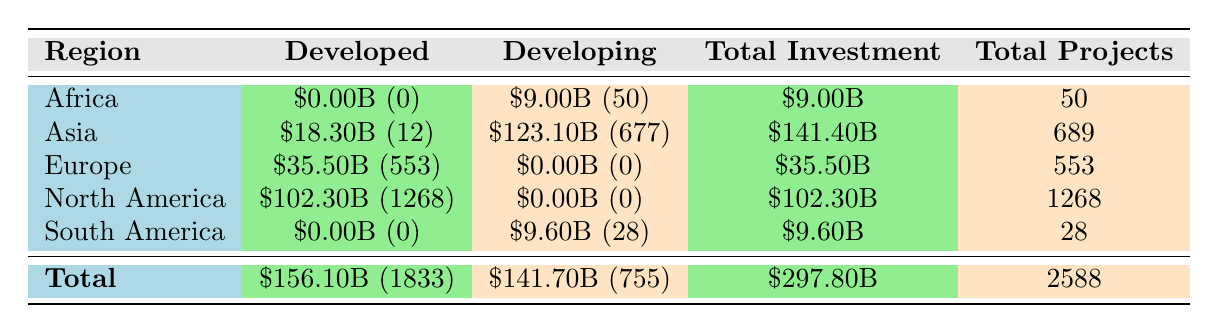What is the total investment in developed nations in Africa? According to the table, the investment in developed nations in Africa is \$0.00B. The amount is clearly listed under the "Developed" column for the "Africa" region.
Answer: 0.00B Which region has the highest total investment? By looking at the "Total Investment" column and comparing the values, Asia has the highest total investment at \$141.40B. This is determined by reviewing all total investment amounts from each region.
Answer: Asia: 141.40B How many projects are there in total across all developing nations? The total number of projects listed under "Developing" is 755, as specified in the table. This is simply retrieved from the corresponding column.
Answer: 755 What is the difference in total investment between developed and developing nations? The total investment for developed nations is \$156.10B, while for developing nations it is \$141.70B. The difference is calculated by subtracting: \$156.10B - \$141.70B = \$14.40B.
Answer: 14.40B Did any developed nation invest in South America? No, the table shows that there is \$0.00B investment listed under the "Developed" category for South America; therefore, none invested.
Answer: No 